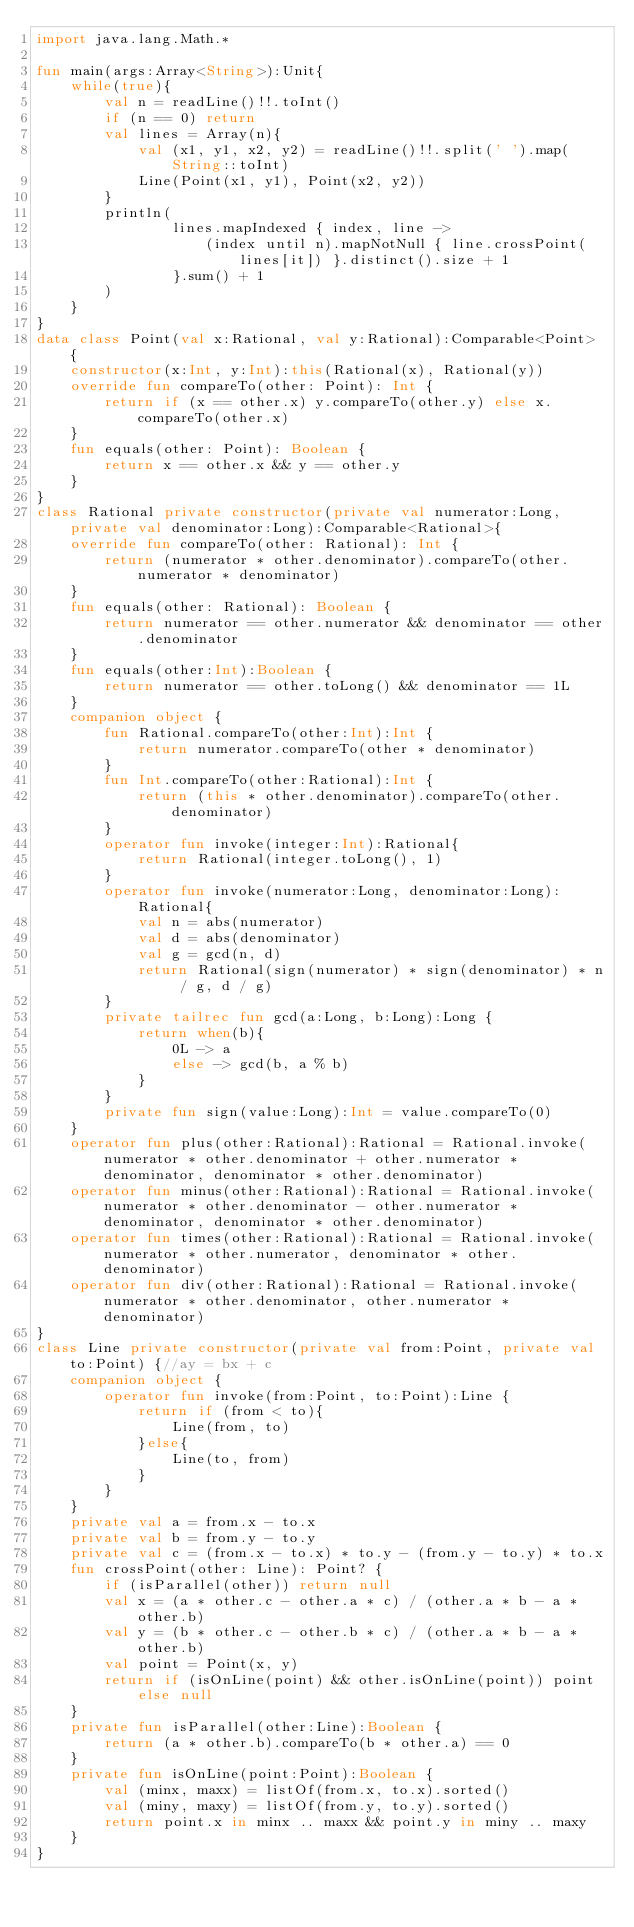<code> <loc_0><loc_0><loc_500><loc_500><_Kotlin_>import java.lang.Math.*

fun main(args:Array<String>):Unit{
    while(true){
        val n = readLine()!!.toInt()
        if (n == 0) return
        val lines = Array(n){
            val (x1, y1, x2, y2) = readLine()!!.split(' ').map(String::toInt)
            Line(Point(x1, y1), Point(x2, y2))
        }
        println(
                lines.mapIndexed { index, line ->
                    (index until n).mapNotNull { line.crossPoint(lines[it]) }.distinct().size + 1
                }.sum() + 1
        )
    }
}
data class Point(val x:Rational, val y:Rational):Comparable<Point> {
    constructor(x:Int, y:Int):this(Rational(x), Rational(y))
    override fun compareTo(other: Point): Int {
        return if (x == other.x) y.compareTo(other.y) else x.compareTo(other.x)
    }
    fun equals(other: Point): Boolean {
        return x == other.x && y == other.y
    }
}
class Rational private constructor(private val numerator:Long, private val denominator:Long):Comparable<Rational>{
    override fun compareTo(other: Rational): Int {
        return (numerator * other.denominator).compareTo(other.numerator * denominator)
    }
    fun equals(other: Rational): Boolean {
        return numerator == other.numerator && denominator == other.denominator
    }
    fun equals(other:Int):Boolean {
        return numerator == other.toLong() && denominator == 1L
    }
    companion object {
        fun Rational.compareTo(other:Int):Int {
            return numerator.compareTo(other * denominator)
        }
        fun Int.compareTo(other:Rational):Int {
            return (this * other.denominator).compareTo(other.denominator)
        }
        operator fun invoke(integer:Int):Rational{
            return Rational(integer.toLong(), 1)
        }
        operator fun invoke(numerator:Long, denominator:Long):Rational{
            val n = abs(numerator)
            val d = abs(denominator)
            val g = gcd(n, d)
            return Rational(sign(numerator) * sign(denominator) * n / g, d / g)
        }
        private tailrec fun gcd(a:Long, b:Long):Long {
            return when(b){
                0L -> a
                else -> gcd(b, a % b)
            }
        }
        private fun sign(value:Long):Int = value.compareTo(0)
    }
    operator fun plus(other:Rational):Rational = Rational.invoke(numerator * other.denominator + other.numerator * denominator, denominator * other.denominator)
    operator fun minus(other:Rational):Rational = Rational.invoke(numerator * other.denominator - other.numerator * denominator, denominator * other.denominator)
    operator fun times(other:Rational):Rational = Rational.invoke(numerator * other.numerator, denominator * other.denominator)
    operator fun div(other:Rational):Rational = Rational.invoke(numerator * other.denominator, other.numerator * denominator)
}
class Line private constructor(private val from:Point, private val to:Point) {//ay = bx + c
    companion object {
        operator fun invoke(from:Point, to:Point):Line {
            return if (from < to){
                Line(from, to)
            }else{
                Line(to, from)
            }
        }
    }
    private val a = from.x - to.x
    private val b = from.y - to.y
    private val c = (from.x - to.x) * to.y - (from.y - to.y) * to.x
    fun crossPoint(other: Line): Point? {
        if (isParallel(other)) return null
        val x = (a * other.c - other.a * c) / (other.a * b - a * other.b)
        val y = (b * other.c - other.b * c) / (other.a * b - a * other.b)
        val point = Point(x, y)
        return if (isOnLine(point) && other.isOnLine(point)) point else null
    }
    private fun isParallel(other:Line):Boolean {
        return (a * other.b).compareTo(b * other.a) == 0
    }
    private fun isOnLine(point:Point):Boolean {
        val (minx, maxx) = listOf(from.x, to.x).sorted()
        val (miny, maxy) = listOf(from.y, to.y).sorted()
        return point.x in minx .. maxx && point.y in miny .. maxy
    }
}
</code> 